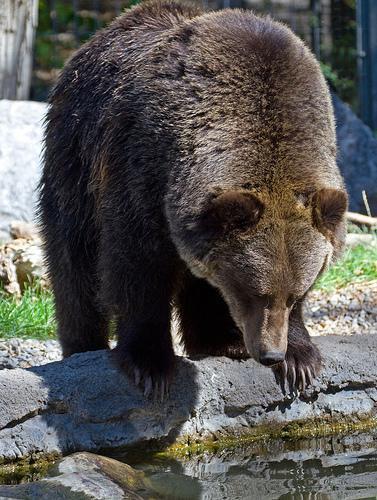How many animals are in this picture?
Give a very brief answer. 1. How many animals can be seen?
Give a very brief answer. 1. 